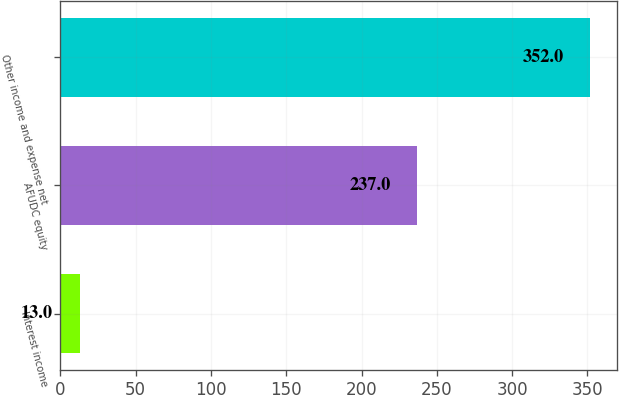Convert chart. <chart><loc_0><loc_0><loc_500><loc_500><bar_chart><fcel>Interest income<fcel>AFUDC equity<fcel>Other income and expense net<nl><fcel>13<fcel>237<fcel>352<nl></chart> 